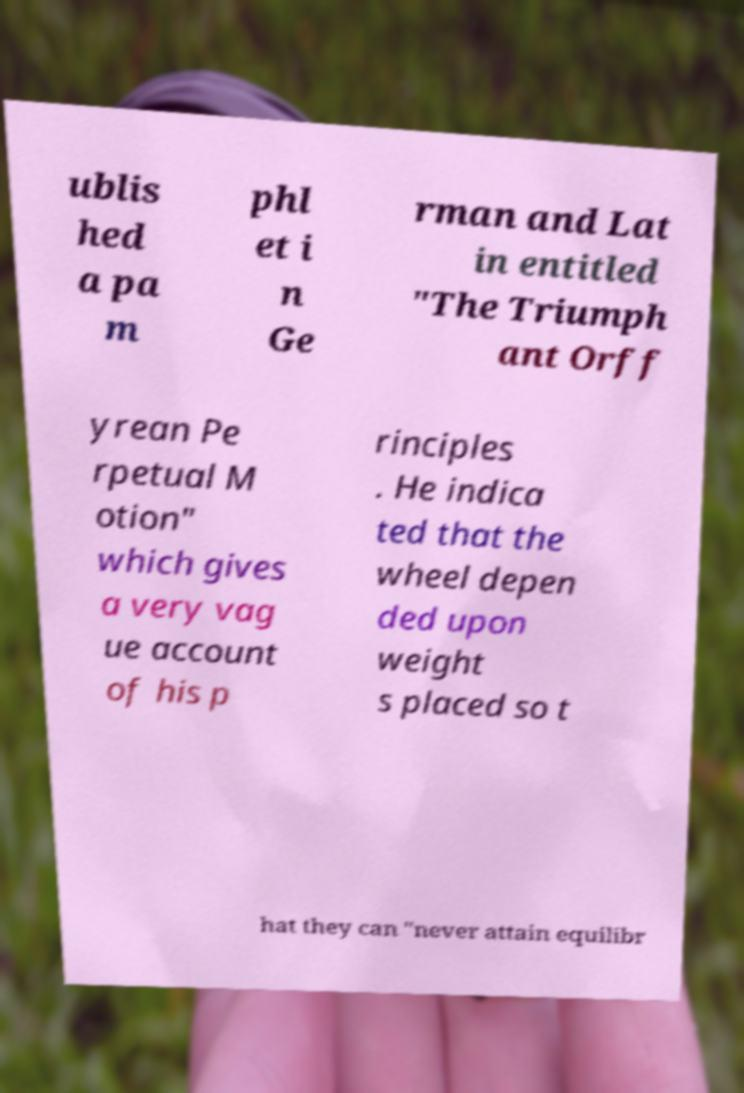For documentation purposes, I need the text within this image transcribed. Could you provide that? ublis hed a pa m phl et i n Ge rman and Lat in entitled "The Triumph ant Orff yrean Pe rpetual M otion" which gives a very vag ue account of his p rinciples . He indica ted that the wheel depen ded upon weight s placed so t hat they can "never attain equilibr 